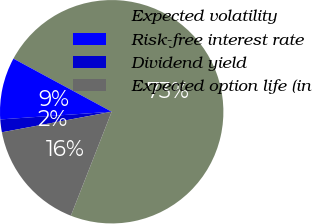Convert chart to OTSL. <chart><loc_0><loc_0><loc_500><loc_500><pie_chart><fcel>Expected volatility<fcel>Risk-free interest rate<fcel>Dividend yield<fcel>Expected option life (in<nl><fcel>73.07%<fcel>8.98%<fcel>1.85%<fcel>16.1%<nl></chart> 